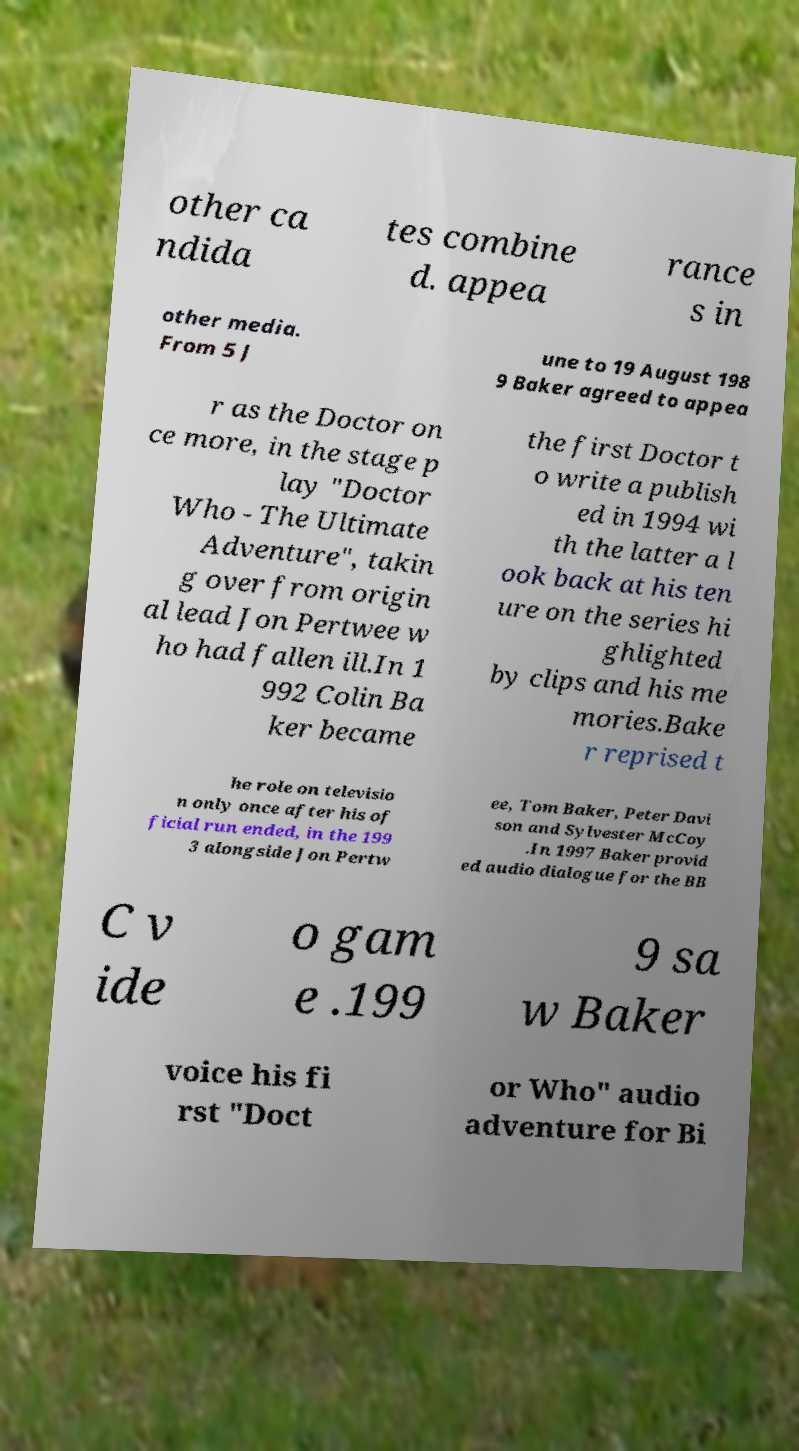Please read and relay the text visible in this image. What does it say? other ca ndida tes combine d. appea rance s in other media. From 5 J une to 19 August 198 9 Baker agreed to appea r as the Doctor on ce more, in the stage p lay "Doctor Who - The Ultimate Adventure", takin g over from origin al lead Jon Pertwee w ho had fallen ill.In 1 992 Colin Ba ker became the first Doctor t o write a publish ed in 1994 wi th the latter a l ook back at his ten ure on the series hi ghlighted by clips and his me mories.Bake r reprised t he role on televisio n only once after his of ficial run ended, in the 199 3 alongside Jon Pertw ee, Tom Baker, Peter Davi son and Sylvester McCoy .In 1997 Baker provid ed audio dialogue for the BB C v ide o gam e .199 9 sa w Baker voice his fi rst "Doct or Who" audio adventure for Bi 